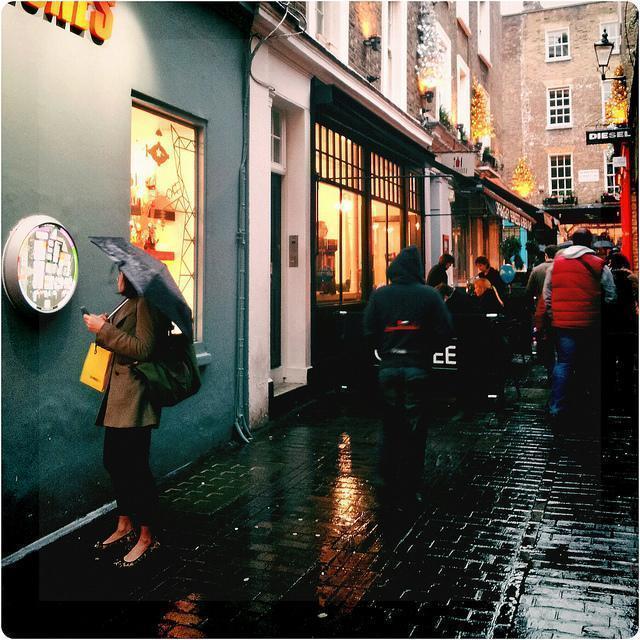What has made the ground shiny?
Select the correct answer and articulate reasoning with the following format: 'Answer: answer
Rationale: rationale.'
Options: Snow, water, wax, oil. Answer: water.
Rationale: The ground is wet from the rain. 